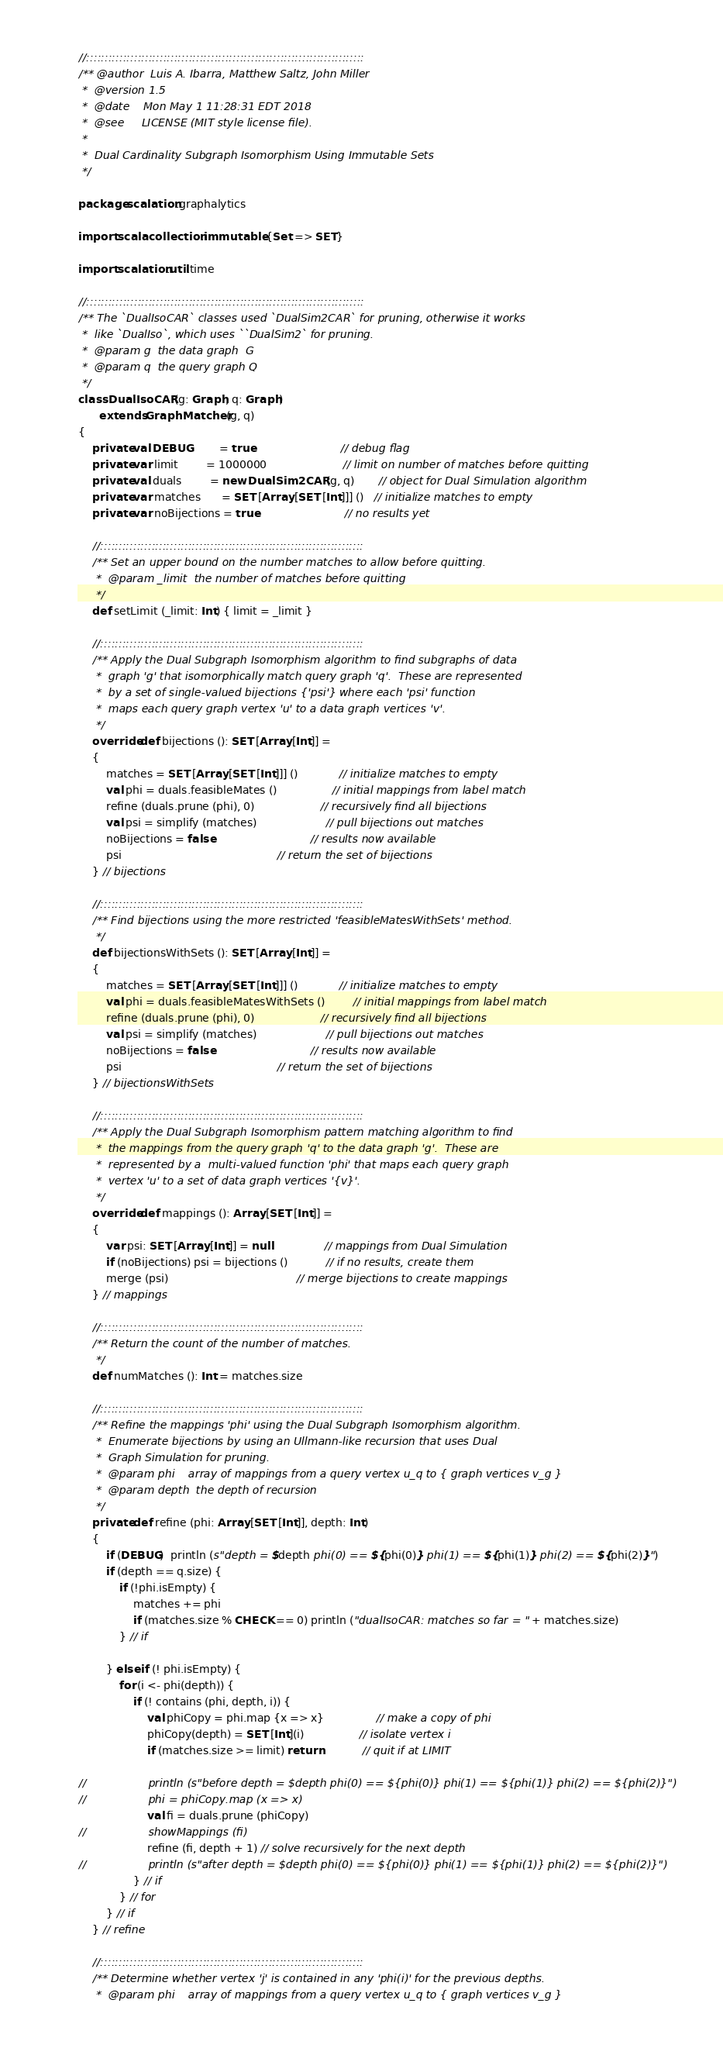<code> <loc_0><loc_0><loc_500><loc_500><_Scala_>
//::::::::::::::::::::::::::::::::::::::::::::::::::::::::::::::::::::::::::::
/** @author  Luis A. Ibarra, Matthew Saltz, John Miller
 *  @version 1.5
 *  @date    Mon May 1 11:28:31 EDT 2018
 *  @see     LICENSE (MIT style license file).
 *
 *  Dual Cardinality Subgraph Isomorphism Using Immutable Sets
 */

package scalation.graphalytics

import scala.collection.immutable.{Set => SET}

import scalation.util.time

//::::::::::::::::::::::::::::::::::::::::::::::::::::::::::::::::::::::::::::
/** The `DualIsoCAR` classes used `DualSim2CAR` for pruning, otherwise it works
 *  like `DualIso`, which uses ``DualSim2` for pruning.
 *  @param g  the data graph  G
 *  @param q  the query graph Q
 */
class DualIsoCAR (g: Graph, q: Graph)
      extends GraphMatcher (g, q)
{
    private val DEBUG        = true                         // debug flag
    private var limit        = 1000000                      // limit on number of matches before quitting
    private val duals        = new DualSim2CAR (g, q)       // object for Dual Simulation algorithm
    private var matches      = SET [Array [SET [Int]]] ()   // initialize matches to empty
    private var noBijections = true                         // no results yet

    //::::::::::::::::::::::::::::::::::::::::::::::::::::::::::::::::::::::::
    /** Set an upper bound on the number matches to allow before quitting.
     *  @param _limit  the number of matches before quitting
     */
    def setLimit (_limit: Int) { limit = _limit }

    //::::::::::::::::::::::::::::::::::::::::::::::::::::::::::::::::::::::::
    /** Apply the Dual Subgraph Isomorphism algorithm to find subgraphs of data
     *  graph 'g' that isomorphically match query graph 'q'.  These are represented
     *  by a set of single-valued bijections {'psi'} where each 'psi' function
     *  maps each query graph vertex 'u' to a data graph vertices 'v'.
     */
    override def bijections (): SET [Array [Int]] =
    {
        matches = SET [Array [SET [Int]]] ()            // initialize matches to empty
        val phi = duals.feasibleMates ()                // initial mappings from label match
        refine (duals.prune (phi), 0)                   // recursively find all bijections
        val psi = simplify (matches)                    // pull bijections out matches
        noBijections = false                            // results now available
        psi                                             // return the set of bijections
    } // bijections

    //::::::::::::::::::::::::::::::::::::::::::::::::::::::::::::::::::::::::
    /** Find bijections using the more restricted 'feasibleMatesWithSets' method.
     */
    def bijectionsWithSets (): SET [Array [Int]] =
    {
        matches = SET [Array [SET [Int]]] ()            // initialize matches to empty
        val phi = duals.feasibleMatesWithSets ()        // initial mappings from label match
        refine (duals.prune (phi), 0)                   // recursively find all bijections
        val psi = simplify (matches)                    // pull bijections out matches
        noBijections = false                            // results now available
        psi                                             // return the set of bijections
    } // bijectionsWithSets

    //::::::::::::::::::::::::::::::::::::::::::::::::::::::::::::::::::::::::
    /** Apply the Dual Subgraph Isomorphism pattern matching algorithm to find
     *  the mappings from the query graph 'q' to the data graph 'g'.  These are
     *  represented by a  multi-valued function 'phi' that maps each query graph
     *  vertex 'u' to a set of data graph vertices '{v}'.
     */
    override def mappings (): Array [SET [Int]] =
    {
        var psi: SET [Array [Int]] = null               // mappings from Dual Simulation
        if (noBijections) psi = bijections ()           // if no results, create them
        merge (psi)                                     // merge bijections to create mappings
    } // mappings

    //::::::::::::::::::::::::::::::::::::::::::::::::::::::::::::::::::::::::
    /** Return the count of the number of matches.
     */
    def numMatches (): Int = matches.size

    //::::::::::::::::::::::::::::::::::::::::::::::::::::::::::::::::::::::::
    /** Refine the mappings 'phi' using the Dual Subgraph Isomorphism algorithm.
     *  Enumerate bijections by using an Ullmann-like recursion that uses Dual
     *  Graph Simulation for pruning.
     *  @param phi    array of mappings from a query vertex u_q to { graph vertices v_g }
     *  @param depth  the depth of recursion
     */
    private def refine (phi: Array [SET [Int]], depth: Int)
    {
        if (DEBUG)  println (s"depth = $depth phi(0) == ${phi(0)} phi(1) == ${phi(1)} phi(2) == ${phi(2)}")
        if (depth == q.size) {
            if (!phi.isEmpty) {
                matches += phi
                if (matches.size % CHECK == 0) println ("dualIsoCAR: matches so far = " + matches.size)
            } // if

        } else if (! phi.isEmpty) {
            for (i <- phi(depth)) {
                if (! contains (phi, depth, i)) {
                    val phiCopy = phi.map {x => x}               // make a copy of phi
                    phiCopy(depth) = SET [Int](i)                // isolate vertex i
                    if (matches.size >= limit) return            // quit if at LIMIT

//                  println (s"before depth = $depth phi(0) == ${phi(0)} phi(1) == ${phi(1)} phi(2) == ${phi(2)}")
//                  phi = phiCopy.map (x => x)
                    val fi = duals.prune (phiCopy)
//                  showMappings (fi)
                    refine (fi, depth + 1) // solve recursively for the next depth
//                  println (s"after depth = $depth phi(0) == ${phi(0)} phi(1) == ${phi(1)} phi(2) == ${phi(2)}")
                } // if
            } // for
        } // if
    } // refine

    //::::::::::::::::::::::::::::::::::::::::::::::::::::::::::::::::::::::::
    /** Determine whether vertex 'j' is contained in any 'phi(i)' for the previous depths.
     *  @param phi    array of mappings from a query vertex u_q to { graph vertices v_g }</code> 